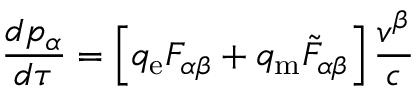Convert formula to latex. <formula><loc_0><loc_0><loc_500><loc_500>{ \frac { d p _ { \alpha } } { d \tau } } = \left [ q _ { e } F _ { \alpha \beta } + q _ { m } { { \tilde { F } } _ { \alpha \beta } } \right ] { \frac { v ^ { \beta } } { c } }</formula> 